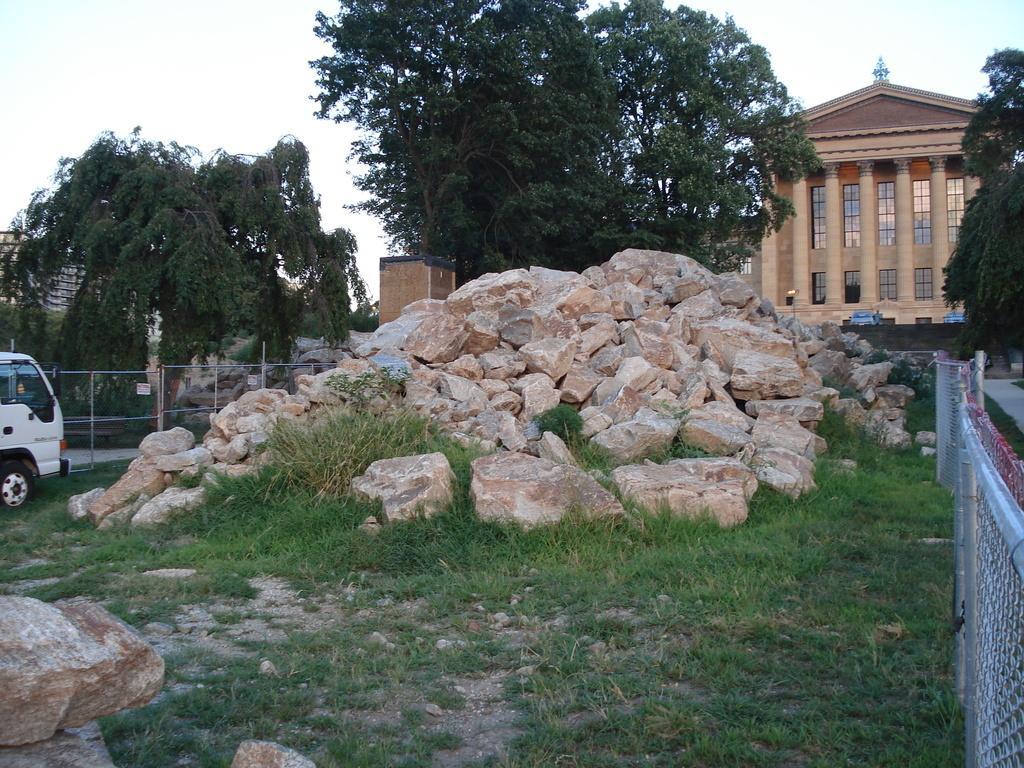How would you summarize this image in a sentence or two? In this picture i can see many stones near to the fencing. On the right i can see the building. On the left there is a white car which is parked near to the stones and fencing. In the background i can see many trees. In the top left corner i can see the sky and clouds. 